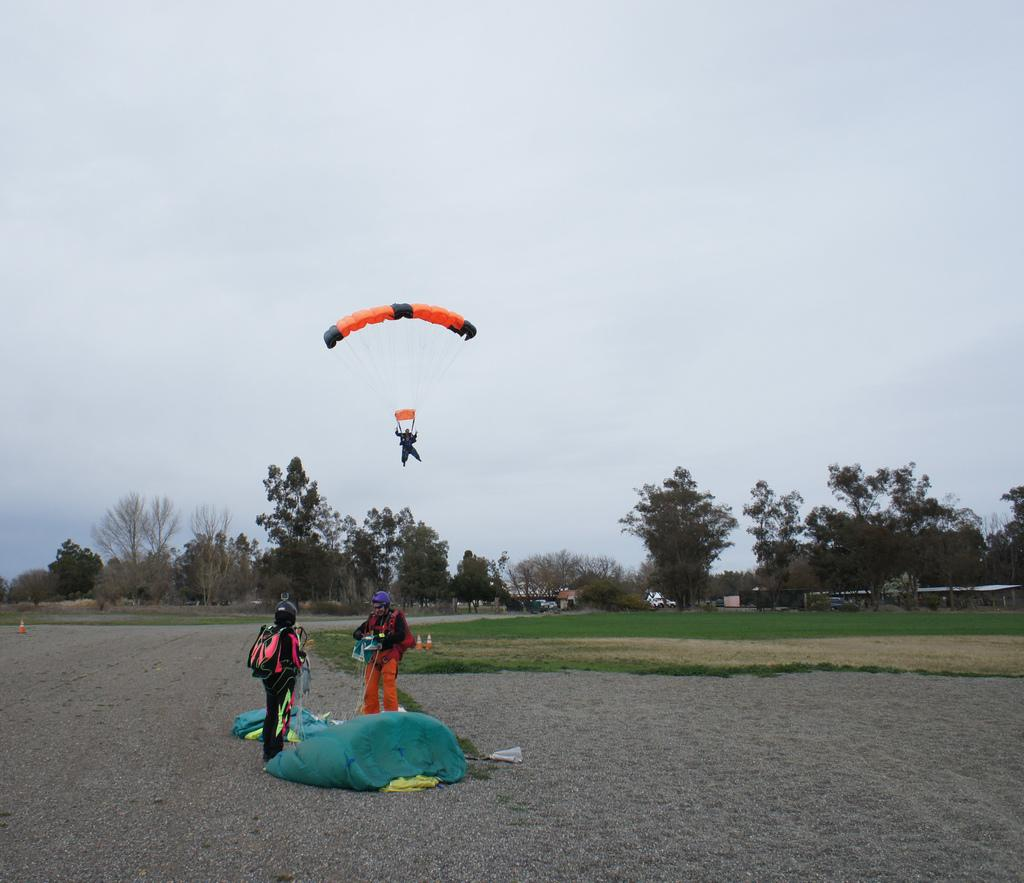How many people are visible in the image? There are 2 people standing on the ground. What is the third person doing in the image? A person is parachuting in the sky. What can be seen in the background of the image? There are trees and buildings in the background. What is visible at the top of the image? The sky is visible at the top of the image. What type of dress is the tree wearing in the image? There are no trees wearing dresses in the image; trees do not wear clothing. What subject is the person teaching in the image? There is no teaching activity depicted in the image. 